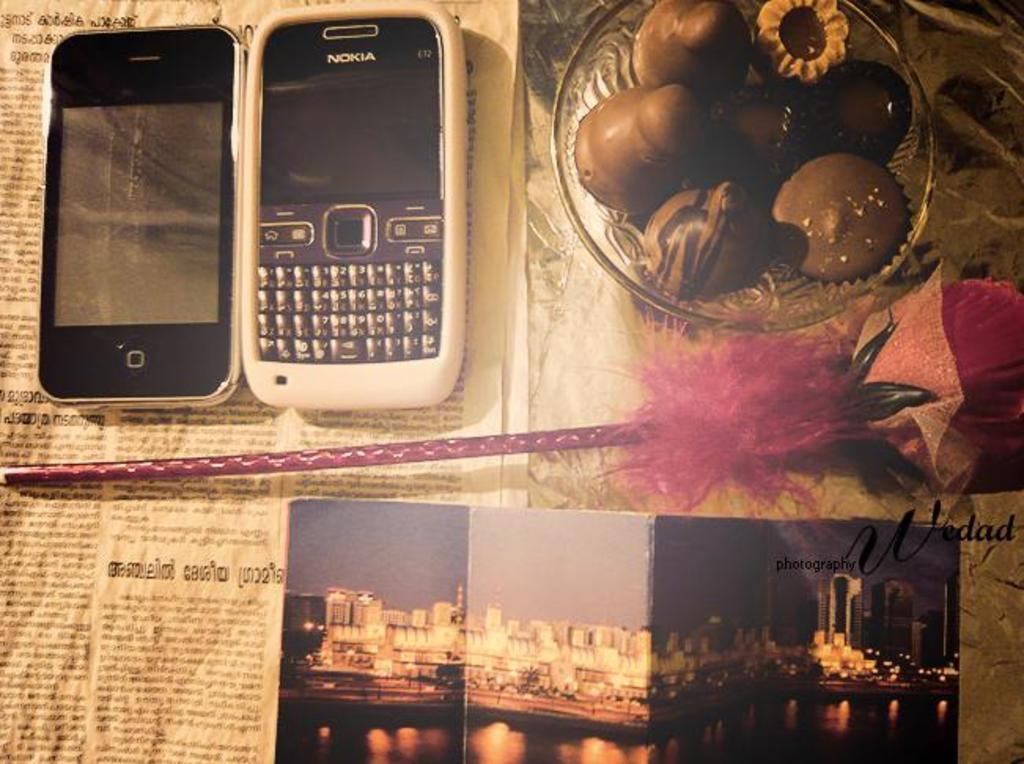<image>
Share a concise interpretation of the image provided. Two phones side by side with one that says NOKIA on it. 